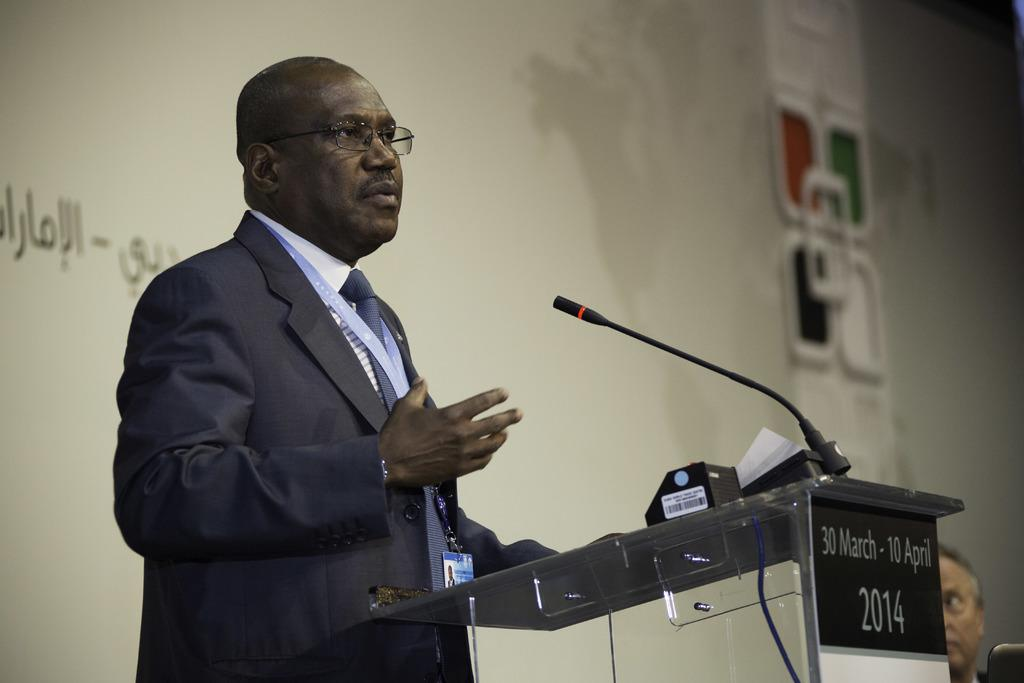What is the man in the image doing? The man is standing in front of a microphone. Can you describe the man's appearance? The man is wearing spectacles. What object is present in the image that is typically used for speeches or presentations? There is a podium in the image. How many people are visible in the image? There is one person, the man, visible in the image. What can be seen in the background of the image? There is a screen in the background of the image. What type of shade is being provided for the baby in the image? There is no baby present in the image, so no shade is being provided for a baby. 